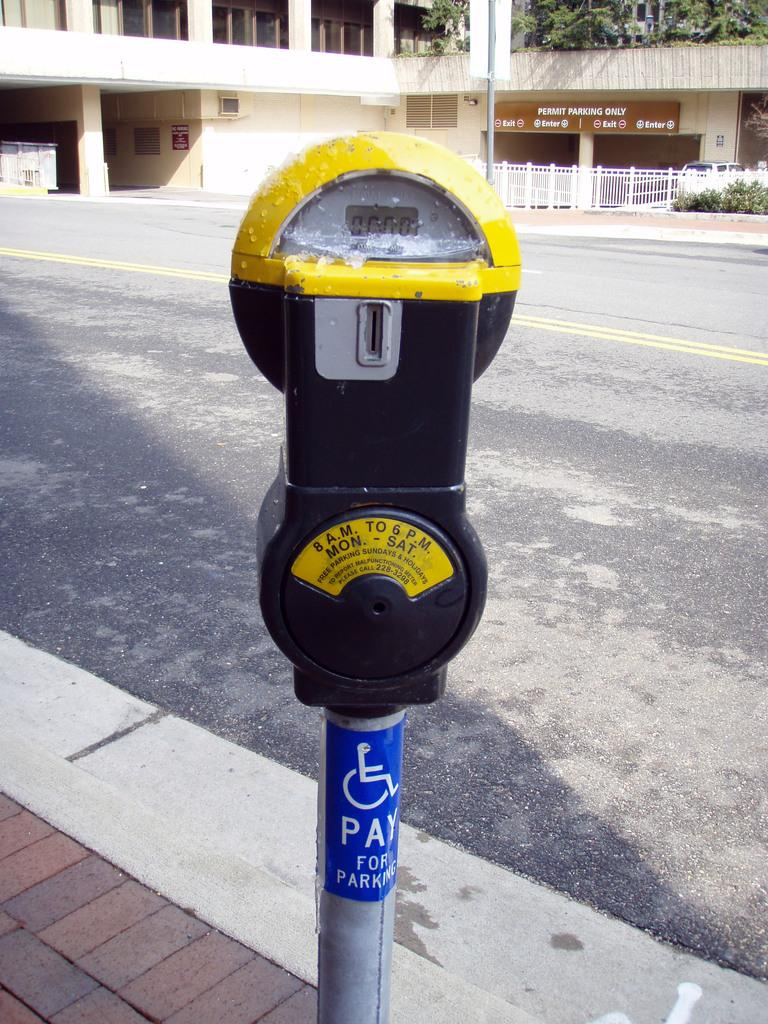<image>
Provide a brief description of the given image. A parking meter with a sticker that says that handicapped must pay for parking. 